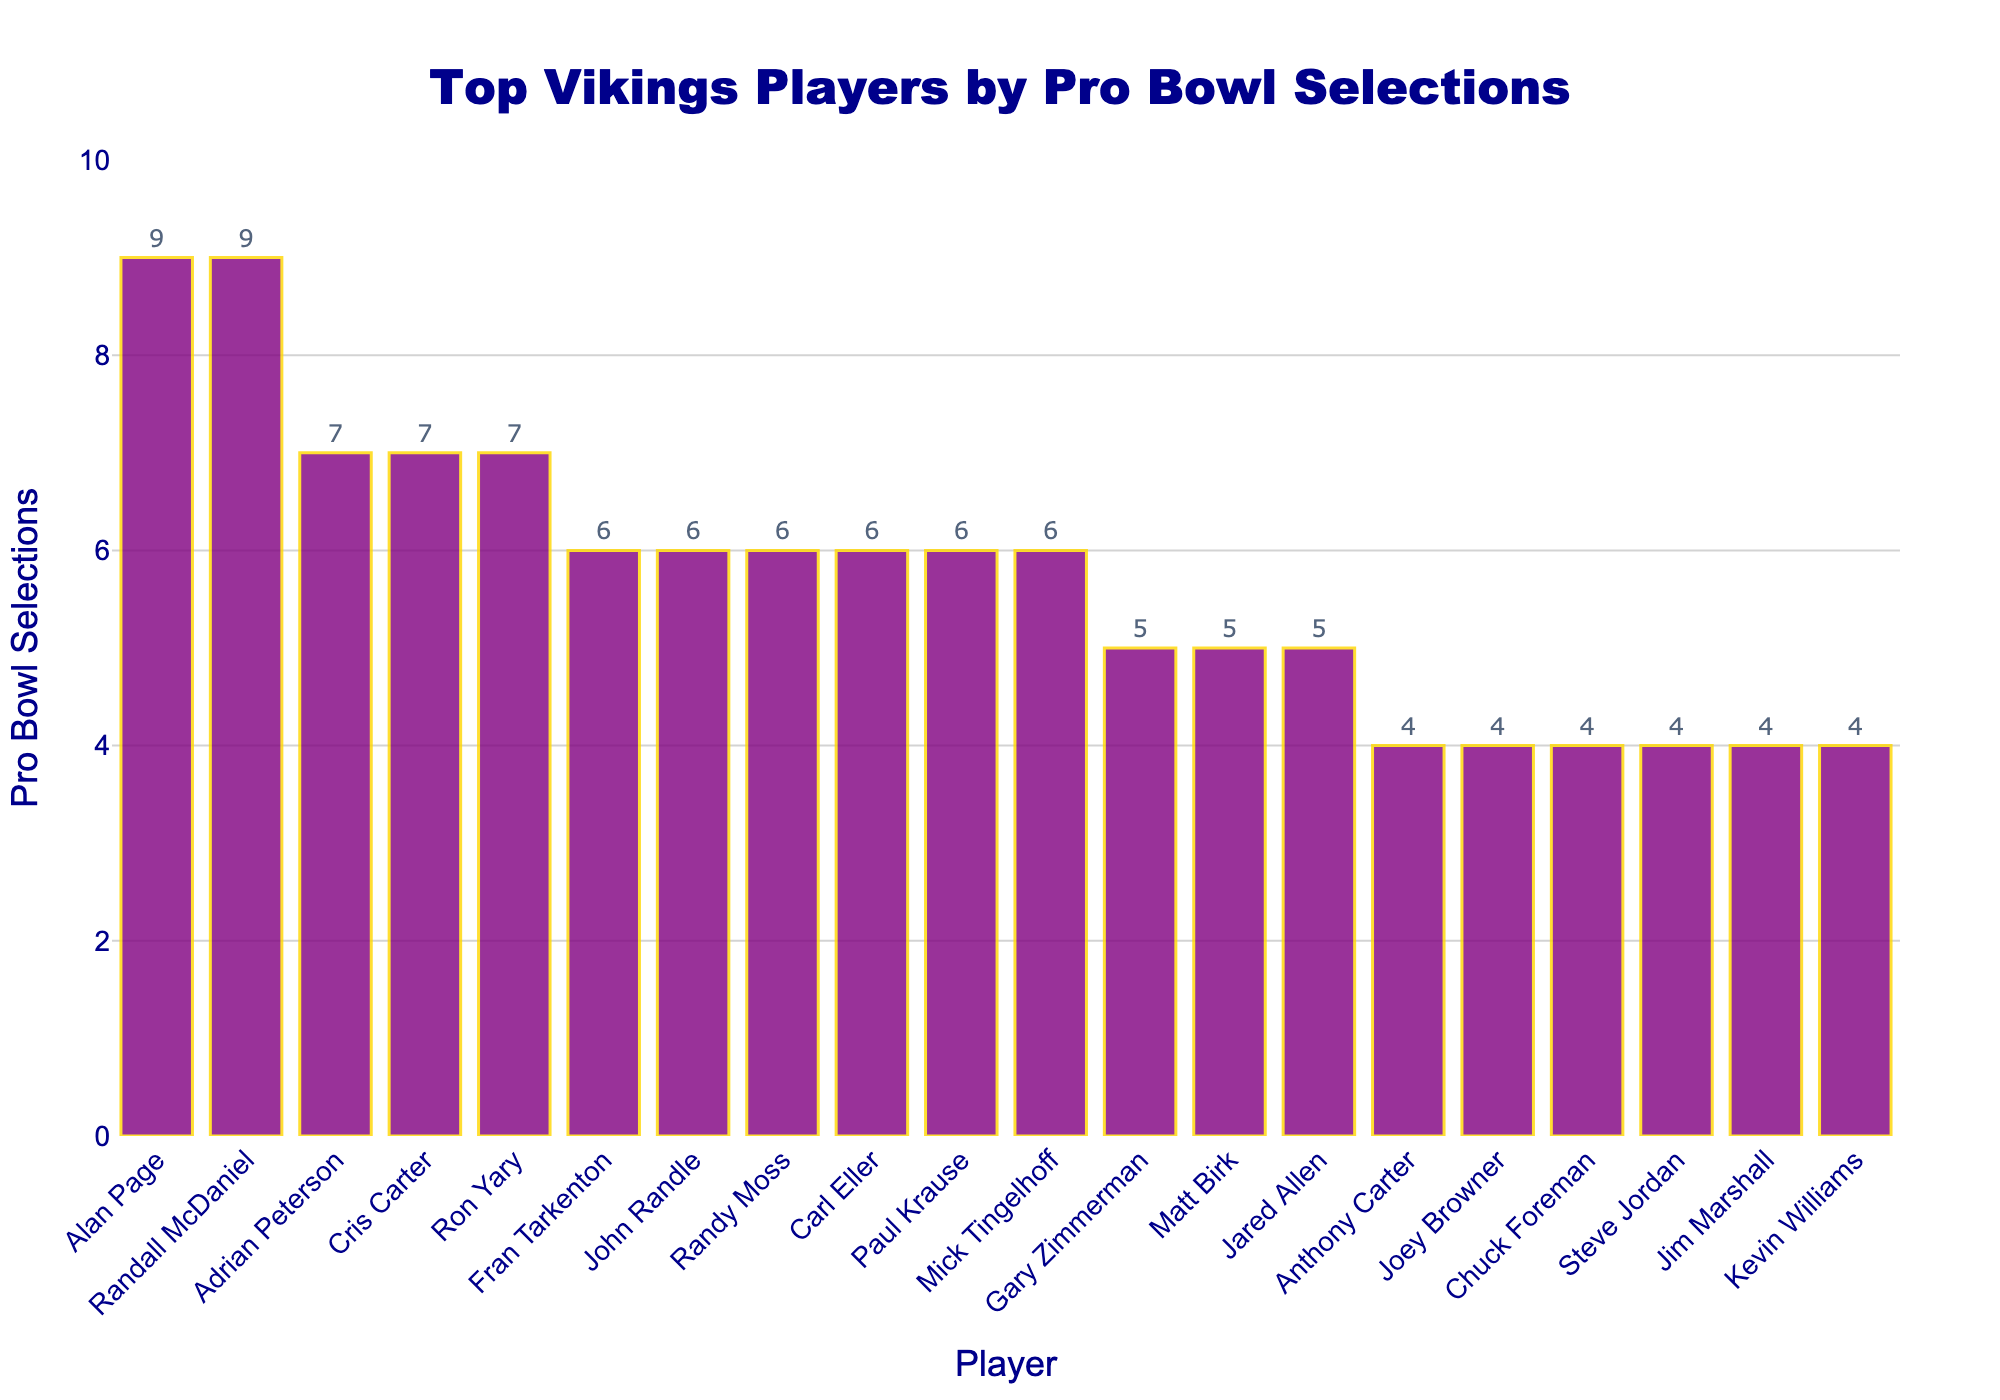Which player has the most Pro Bowl selections? The player with the highest bar represents the player with the most selections. Both Alan Page and Randall McDaniel have the highest bar with 9 selections.
Answer: Alan Page and Randall McDaniel Which players have the same number of Pro Bowl selections as Adrian Peterson? We identify the bar height for Adrian Peterson, which is 7, and then look for other bars of the same height. Cris Carter and Ron Yary also have 7 selections each.
Answer: Cris Carter and Ron Yary What is the total number of Pro Bowl selections for the top three players? Sum the Pro Bowl selections of the top three players. Alan Page (9) + Randall McDaniel (9) + Adrian Peterson (7) = 25.
Answer: 25 How many players have more than 5 Pro Bowl selections? Count the bars that extend higher than 5 on the y-axis. There are 10 players with more than 5 selections.
Answer: 10 Which Vikings player with exactly 6 Pro Bowl selections has a first name starting with 'M'? Identify players with a bar of height 6 and filter by first names starting with 'M'. Mick Tingelhoff meets this criterion.
Answer: Mick Tingelhoff How many fewer Pro Bowl selections does Gary Zimmerman have compared to Adrian Peterson? Subtract Gary Zimmerman's selections (5) from Adrian Peterson's (7): 7 - 5 = 2.
Answer: 2 What's the average number of Pro Bowl selections for the players listed with exactly 4 selections? Sum the Pro Bowl selections for those with exactly 4: (4 + 4 + 4 + 4 + 4) and divide by the number of those players, 5: (4 + 4 + 4 + 4 + 4) / 5 = 4.
Answer: 4 Who are the players with the shortest bars, and how many Pro Bowl selections do they have? Identify the shortest bars at the height of 4. The players are Anthony Carter, Joey Browner, Chuck Foreman, Steve Jordan, Jim Marshall, and Kevin Williams. They each have 4 selections.
Answer: Anthony Carter, Joey Browner, Chuck Foreman, Steve Jordan, Jim Marshall, and Kevin Williams What is the difference in the number of Pro Bowl selections between the player with the second-highest selections and the player with the most selections? Both Alan Page and Randall McDaniel have the most selections (9). The difference between the second-highest (also 9) and the highest is zero.
Answer: 0 